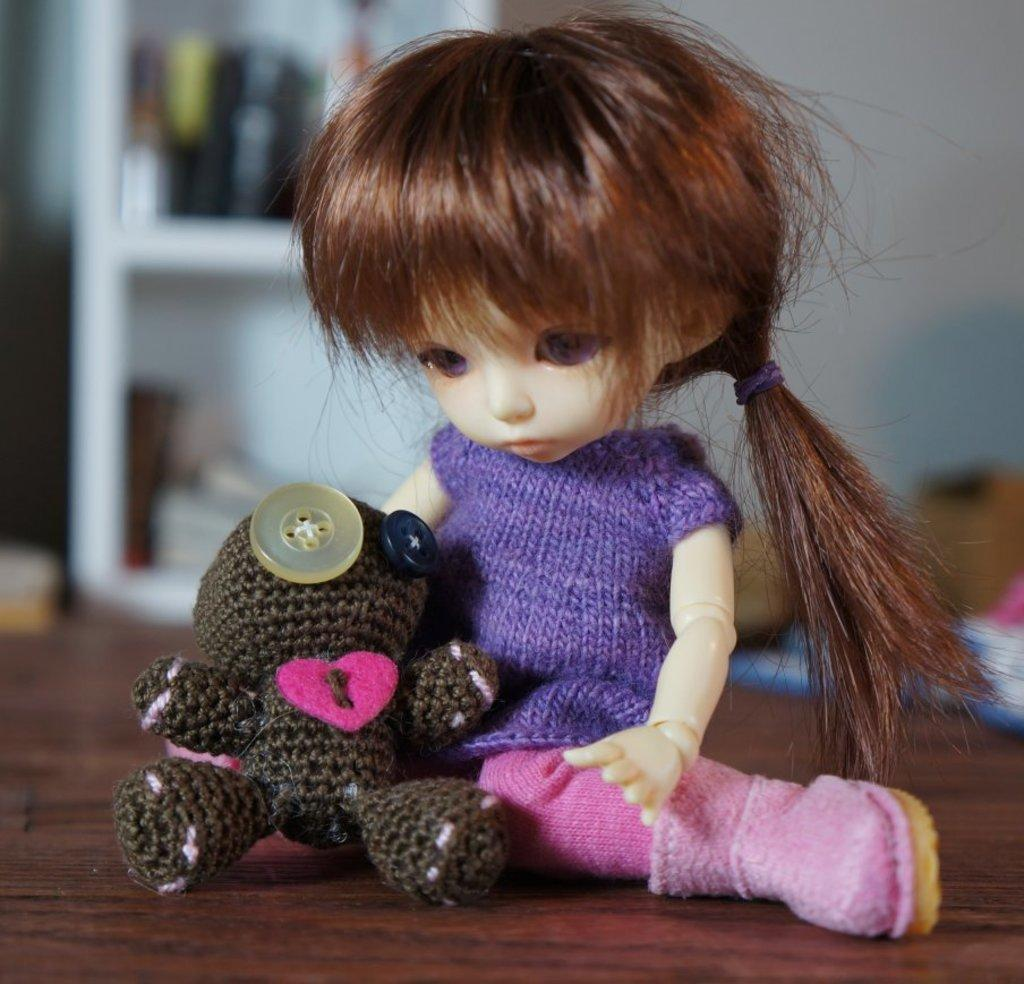What type of objects are present on the wooden surface in the image? There are soft toys on the wooden surface in the image. Can you describe the surface on which the soft toys are placed? The wooden surface is visible in the image. What can be seen in the background of the image? There are objects visible in the background of the image. How would you describe the clarity of the background in the image? The background of the image is blurred. What type of wire is being used to create the whistling sound in the image? There is no wire or whistling sound present in the image; it features soft toys on a wooden surface with a blurred background. 